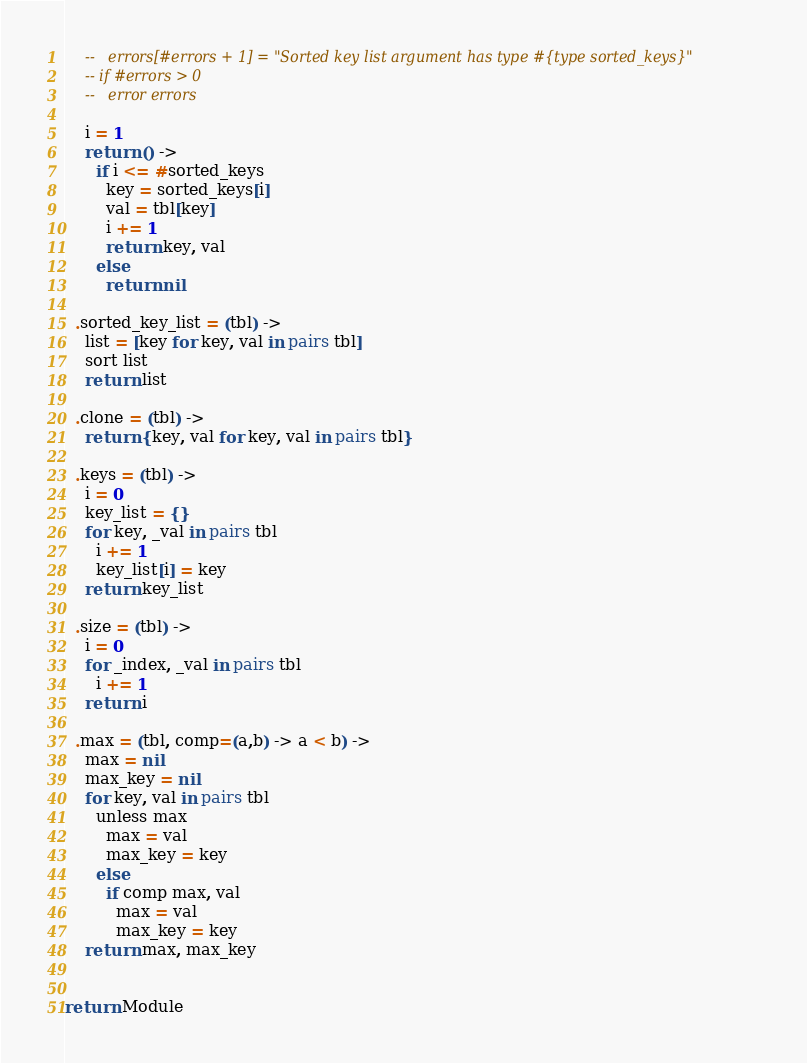Convert code to text. <code><loc_0><loc_0><loc_500><loc_500><_MoonScript_>    --   errors[#errors + 1] = "Sorted key list argument has type #{type sorted_keys}"
    -- if #errors > 0
    --   error errors

    i = 1
    return () ->
      if i <= #sorted_keys
        key = sorted_keys[i]
        val = tbl[key]
        i += 1
        return key, val
      else
        return nil

  .sorted_key_list = (tbl) ->
    list = [key for key, val in pairs tbl]
    sort list
    return list

  .clone = (tbl) ->
    return {key, val for key, val in pairs tbl}

  .keys = (tbl) ->
    i = 0
    key_list = {}
    for key, _val in pairs tbl
      i += 1
      key_list[i] = key
    return key_list

  .size = (tbl) ->
    i = 0
    for _index, _val in pairs tbl
      i += 1
    return i

  .max = (tbl, comp=(a,b) -> a < b) ->
    max = nil
    max_key = nil
    for key, val in pairs tbl
      unless max
        max = val
        max_key = key
      else
        if comp max, val
          max = val
          max_key = key
    return max, max_key


return Module
</code> 